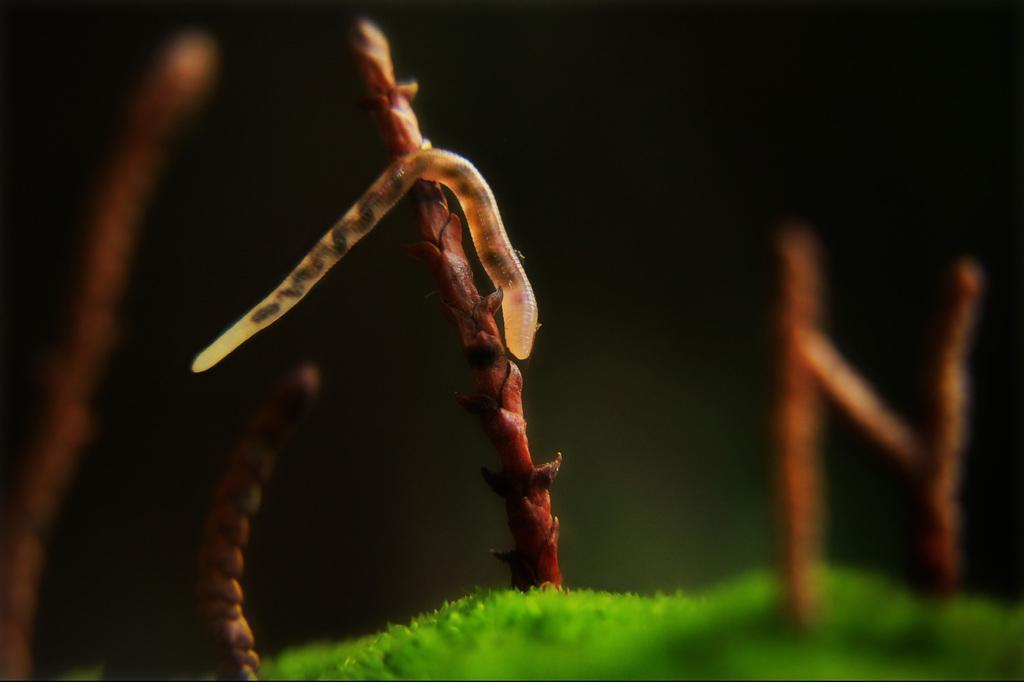Could you give a brief overview of what you see in this image? Above this grass there are stems. On this system there is a worm. 